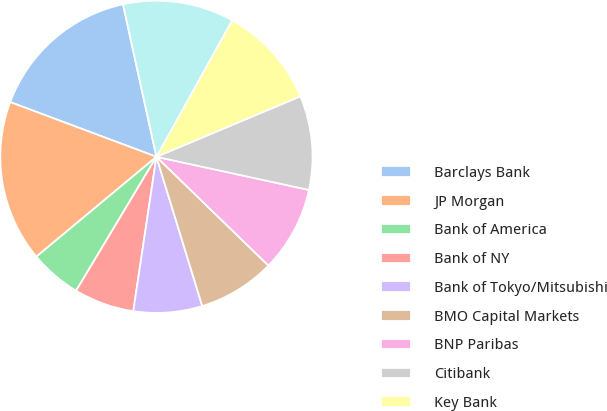Convert chart to OTSL. <chart><loc_0><loc_0><loc_500><loc_500><pie_chart><fcel>Barclays Bank<fcel>JP Morgan<fcel>Bank of America<fcel>Bank of NY<fcel>Bank of Tokyo/Mitsubishi<fcel>BMO Capital Markets<fcel>BNP Paribas<fcel>Citibank<fcel>Key Bank<fcel>Morgan Stanley Bank<nl><fcel>15.87%<fcel>16.74%<fcel>5.36%<fcel>6.23%<fcel>7.11%<fcel>7.99%<fcel>8.86%<fcel>9.74%<fcel>10.61%<fcel>11.49%<nl></chart> 